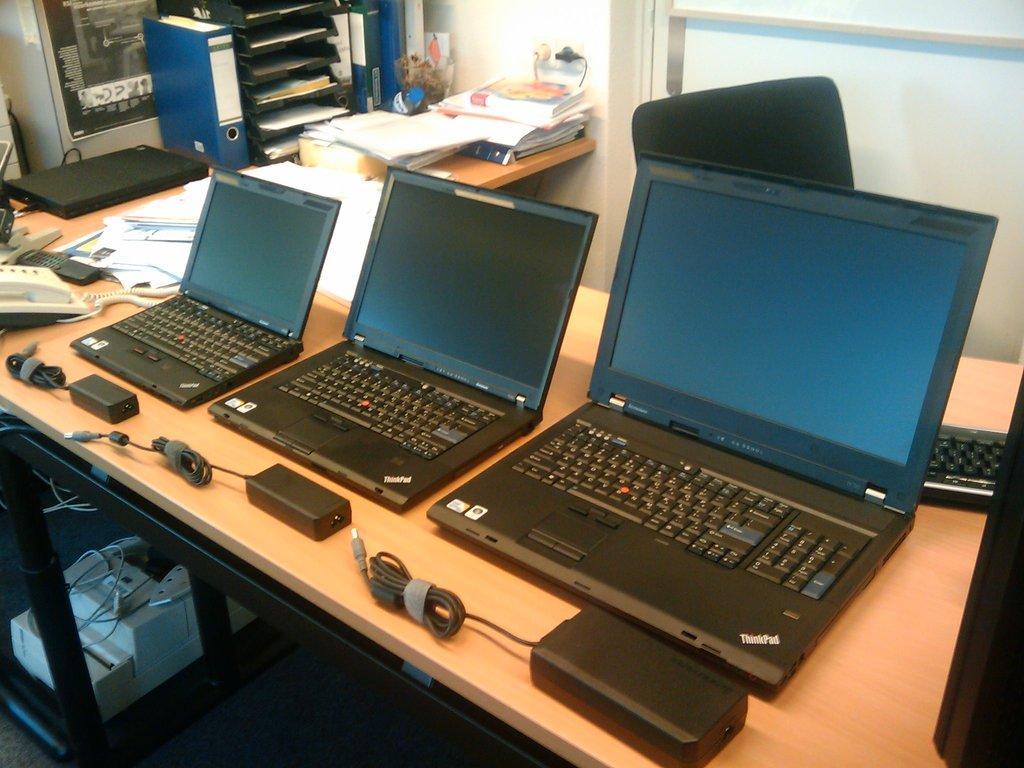Describe this image in one or two sentences. In this picture we can observe three laptops of different sizes placed on the cream color table. We can observe chargers in front of these three laptops. There is a black color chair. We can observe some papers and files on the table. In the background there is a wall. 